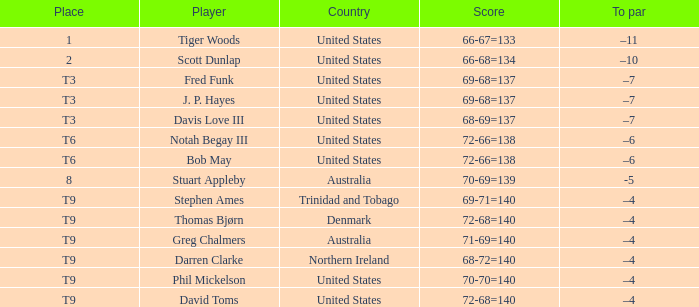What place did Bob May get when his score was 72-66=138? T6. 